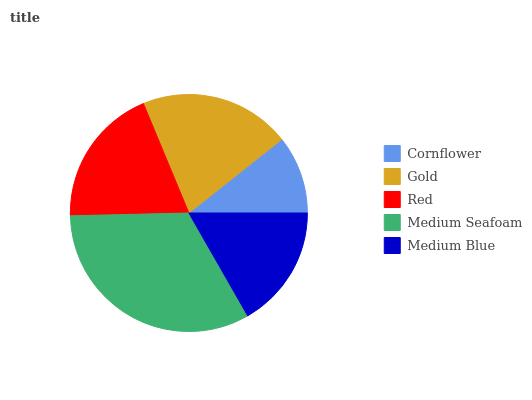Is Cornflower the minimum?
Answer yes or no. Yes. Is Medium Seafoam the maximum?
Answer yes or no. Yes. Is Gold the minimum?
Answer yes or no. No. Is Gold the maximum?
Answer yes or no. No. Is Gold greater than Cornflower?
Answer yes or no. Yes. Is Cornflower less than Gold?
Answer yes or no. Yes. Is Cornflower greater than Gold?
Answer yes or no. No. Is Gold less than Cornflower?
Answer yes or no. No. Is Red the high median?
Answer yes or no. Yes. Is Red the low median?
Answer yes or no. Yes. Is Cornflower the high median?
Answer yes or no. No. Is Gold the low median?
Answer yes or no. No. 